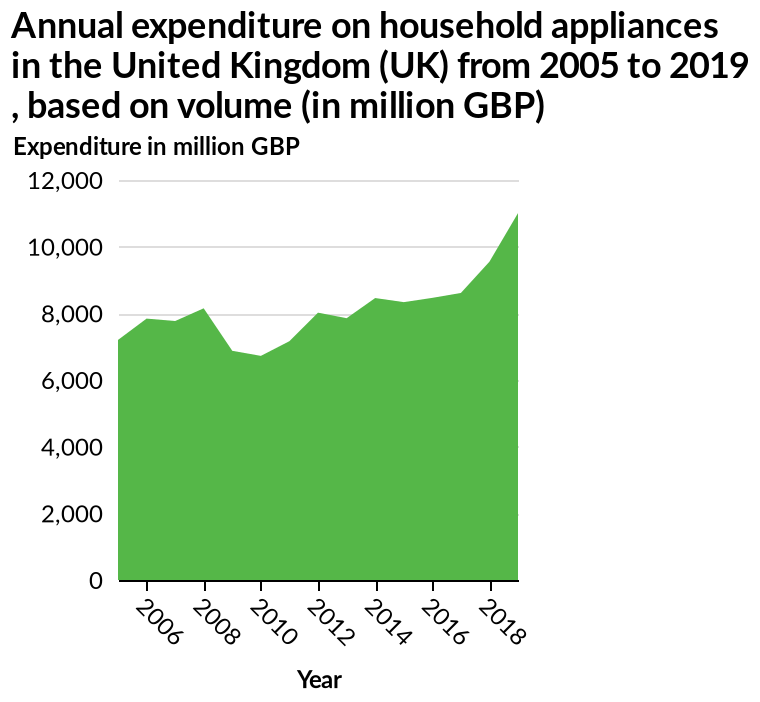<image>
When was the highest expenditure recorded?  The highest expenditure was recorded in 2018. What is the range of the y-axis scale? The y-axis scale ranges from 0 to 12,000 on a linear scale. What does the y-axis measure? The y-axis measures the expenditure in million GBP. please summary the statistics and relations of the chart The lowest expenditure was in 2010. The highest expenditure was in 2018. Mostly expenditure lies within 6000 and 8000. Does the y-axis scale range from 0 to 100,000 on a linear scale? No.The y-axis scale ranges from 0 to 12,000 on a linear scale. 